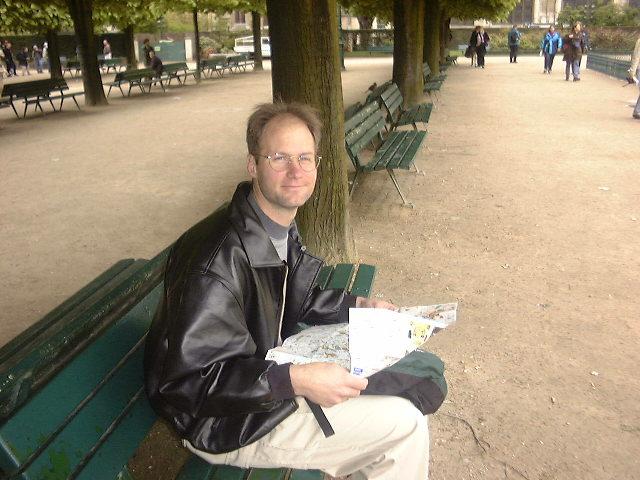Is the man longer than the length of the bench?
Quick response, please. Yes. Is this guy balding?
Quick response, please. Yes. Why is he smiling?
Answer briefly. Happy. What helps this man see us better?
Answer briefly. Glasses. 